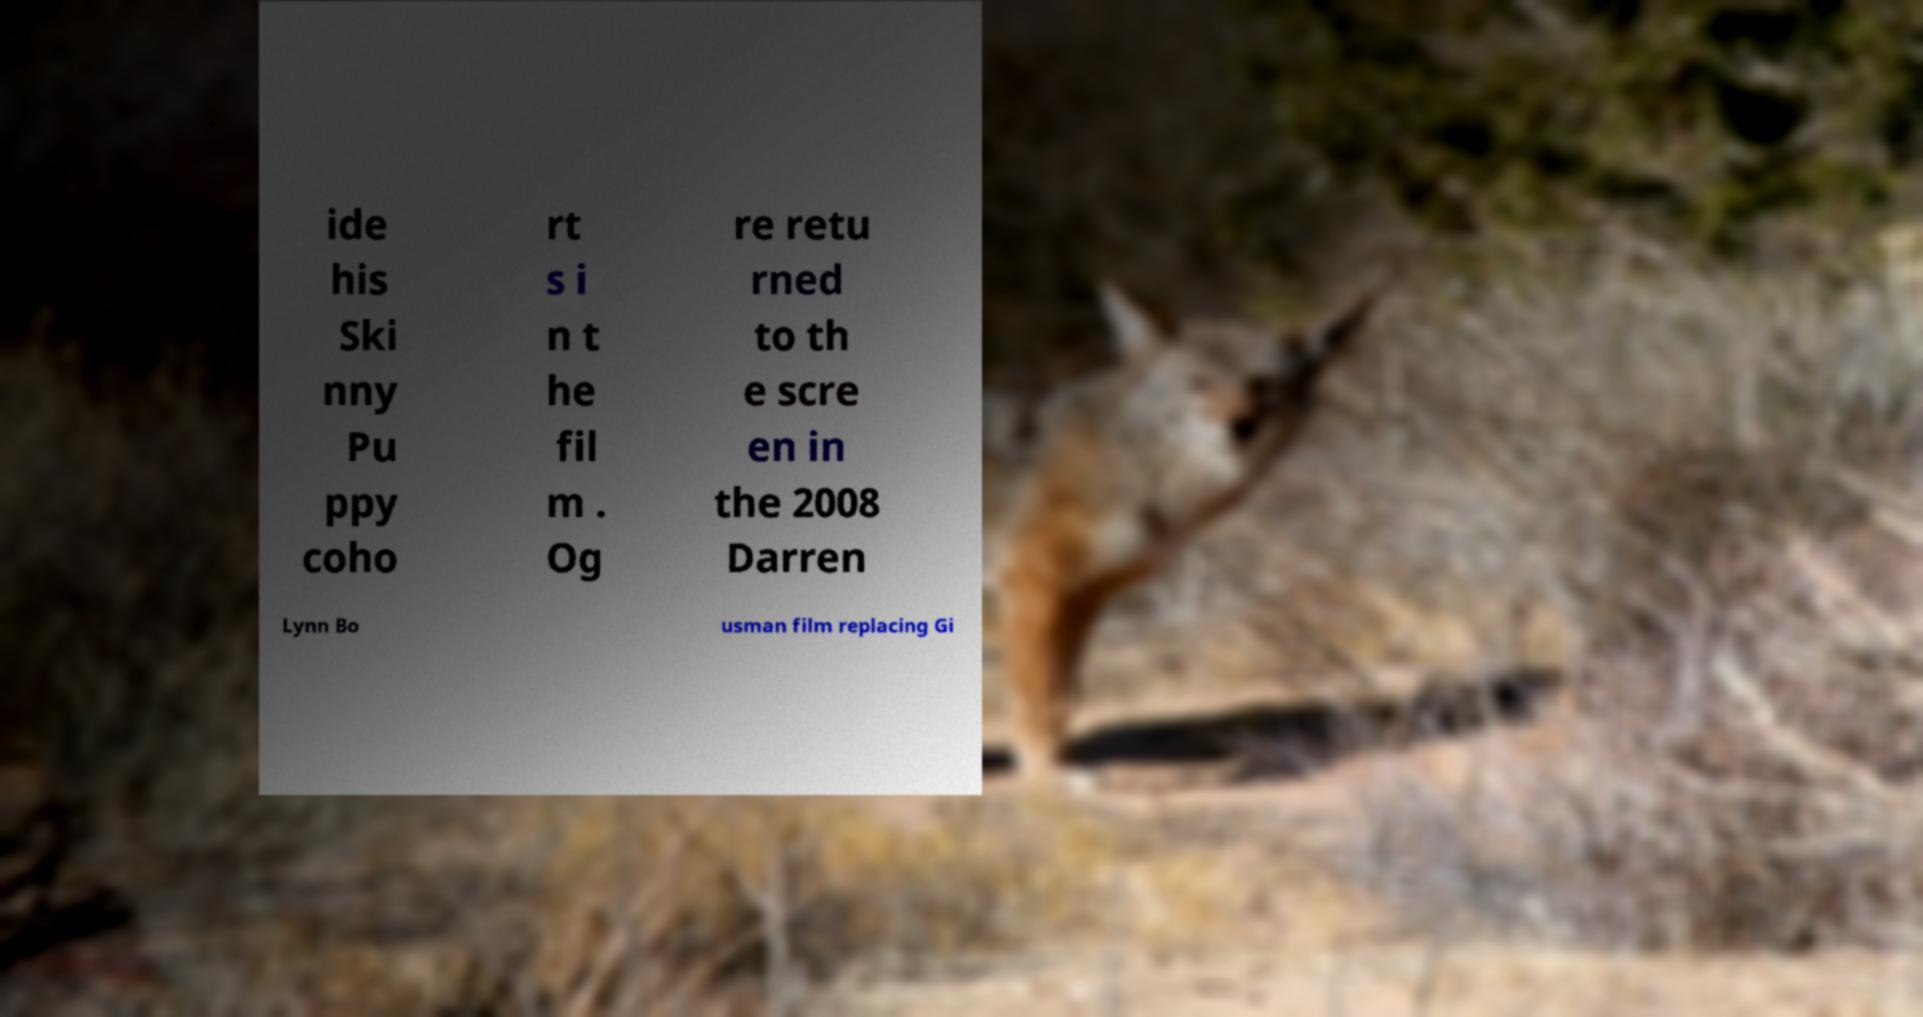Please read and relay the text visible in this image. What does it say? ide his Ski nny Pu ppy coho rt s i n t he fil m . Og re retu rned to th e scre en in the 2008 Darren Lynn Bo usman film replacing Gi 